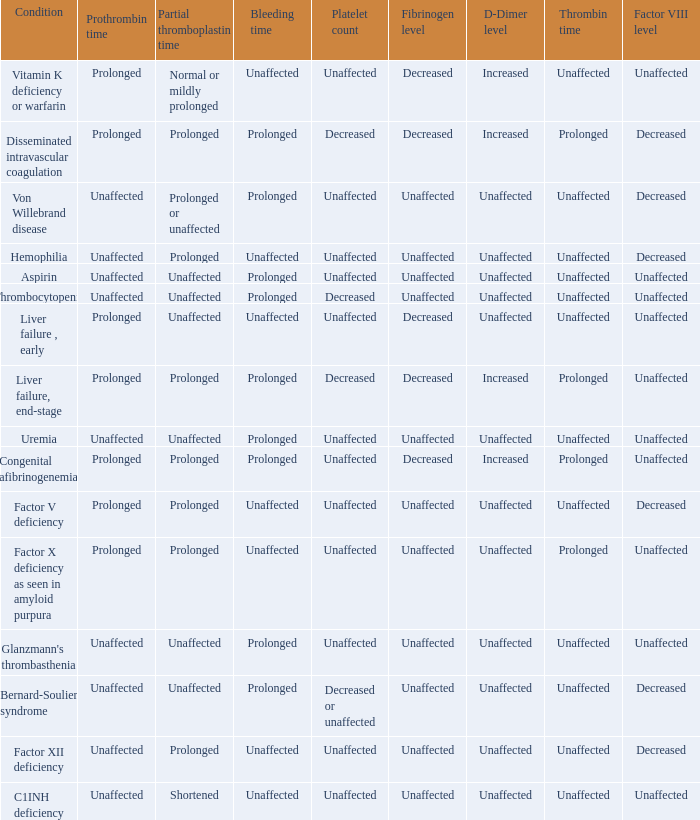Would you be able to parse every entry in this table? {'header': ['Condition', 'Prothrombin time', 'Partial thromboplastin time', 'Bleeding time', 'Platelet count', 'Fibrinogen level', 'D-Dimer level', 'Thrombin time', 'Factor VIII level'], 'rows': [['Vitamin K deficiency or warfarin', 'Prolonged', 'Normal or mildly prolonged', 'Unaffected', 'Unaffected', 'Decreased', 'Increased', 'Unaffected', 'Unaffected'], ['Disseminated intravascular coagulation', 'Prolonged', 'Prolonged', 'Prolonged', 'Decreased', 'Decreased', 'Increased', 'Prolonged', 'Decreased'], ['Von Willebrand disease', 'Unaffected', 'Prolonged or unaffected', 'Prolonged', 'Unaffected', 'Unaffected', 'Unaffected', 'Unaffected', 'Decreased'], ['Hemophilia', 'Unaffected', 'Prolonged', 'Unaffected', 'Unaffected', 'Unaffected', 'Unaffected', 'Unaffected', 'Decreased'], ['Aspirin', 'Unaffected', 'Unaffected', 'Prolonged', 'Unaffected', 'Unaffected', 'Unaffected', 'Unaffected', 'Unaffected'], ['Thrombocytopenia', 'Unaffected', 'Unaffected', 'Prolonged', 'Decreased', 'Unaffected', 'Unaffected', 'Unaffected', 'Unaffected'], ['Liver failure , early', 'Prolonged', 'Unaffected', 'Unaffected', 'Unaffected', 'Decreased', 'Unaffected', 'Unaffected', 'Unaffected'], ['Liver failure, end-stage', 'Prolonged', 'Prolonged', 'Prolonged', 'Decreased', 'Decreased', 'Increased', 'Prolonged', 'Unaffected'], ['Uremia', 'Unaffected', 'Unaffected', 'Prolonged', 'Unaffected', 'Unaffected', 'Unaffected', 'Unaffected', 'Unaffected'], ['Congenital afibrinogenemia', 'Prolonged', 'Prolonged', 'Prolonged', 'Unaffected', 'Decreased', 'Increased', 'Prolonged', 'Unaffected'], ['Factor V deficiency', 'Prolonged', 'Prolonged', 'Unaffected', 'Unaffected', 'Unaffected', 'Unaffected', 'Unaffected', 'Decreased'], ['Factor X deficiency as seen in amyloid purpura', 'Prolonged', 'Prolonged', 'Unaffected', 'Unaffected', 'Unaffected', 'Unaffected', 'Prolonged', 'Unaffected'], ["Glanzmann's thrombasthenia", 'Unaffected', 'Unaffected', 'Prolonged', 'Unaffected', 'Unaffected', 'Unaffected', 'Unaffected', 'Unaffected'], ['Bernard-Soulier syndrome', 'Unaffected', 'Unaffected', 'Prolonged', 'Decreased or unaffected', 'Unaffected', 'Unaffected', 'Unaffected', 'Decreased'], ['Factor XII deficiency', 'Unaffected', 'Prolonged', 'Unaffected', 'Unaffected', 'Unaffected', 'Unaffected', 'Unaffected', 'Decreased'], ['C1INH deficiency', 'Unaffected', 'Shortened', 'Unaffected', 'Unaffected', 'Unaffected', 'Unaffected', 'Unaffected', 'Unaffected']]} What is hemophilia's bleeding time? Unaffected. 